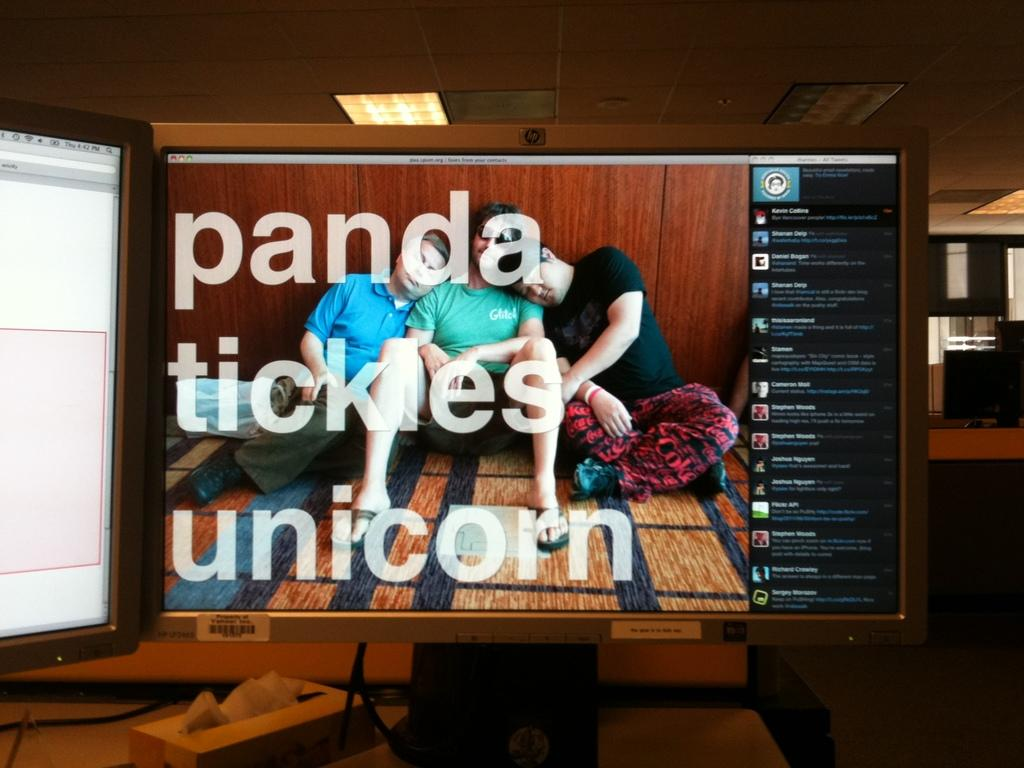<image>
Create a compact narrative representing the image presented. A monitor shows the words, "panda tickles unicorn." 